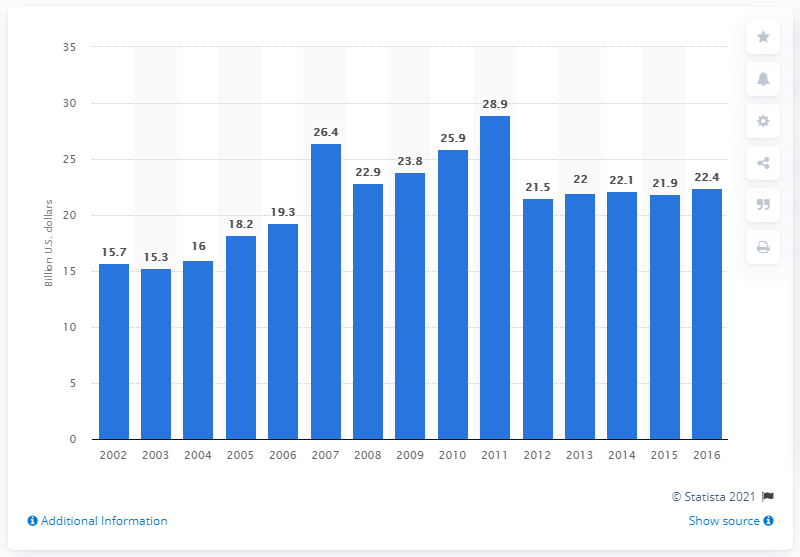Outline some significant characteristics in this image. In 2016, the value of U.S. product shipments of soaps and other detergents was 22.4 million. 